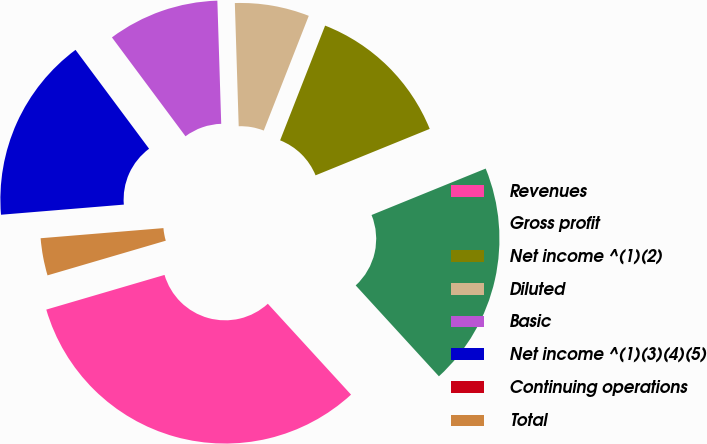Convert chart. <chart><loc_0><loc_0><loc_500><loc_500><pie_chart><fcel>Revenues<fcel>Gross profit<fcel>Net income ^(1)(2)<fcel>Diluted<fcel>Basic<fcel>Net income ^(1)(3)(4)(5)<fcel>Continuing operations<fcel>Total<nl><fcel>32.26%<fcel>19.35%<fcel>12.9%<fcel>6.45%<fcel>9.68%<fcel>16.13%<fcel>0.0%<fcel>3.23%<nl></chart> 